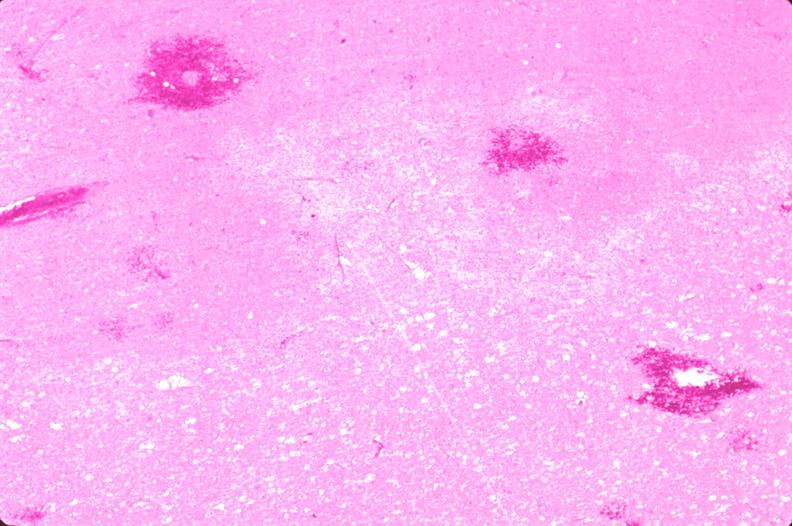what does this image show?
Answer the question using a single word or phrase. Brain 